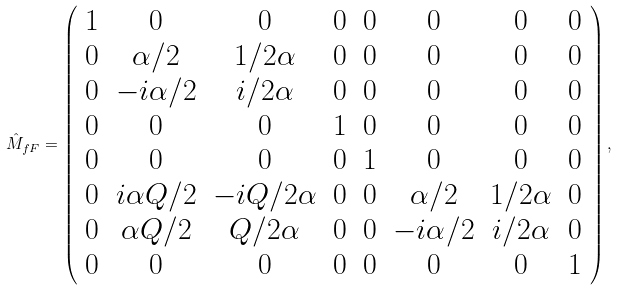Convert formula to latex. <formula><loc_0><loc_0><loc_500><loc_500>\hat { M } _ { f F } = \left ( \begin{array} { c c c c c c c c } 1 & 0 & 0 & 0 & 0 & 0 & 0 & 0 \\ 0 & \alpha / 2 & 1 / 2 \alpha & 0 & 0 & 0 & 0 & 0 \\ 0 & - i \alpha / 2 & i / 2 \alpha & 0 & 0 & 0 & 0 & 0 \\ 0 & 0 & 0 & 1 & 0 & 0 & 0 & 0 \\ 0 & 0 & 0 & 0 & 1 & 0 & 0 & 0 \\ 0 & i \alpha Q / 2 & - i Q / 2 \alpha & 0 & 0 & \alpha / 2 & 1 / 2 \alpha & 0 \\ 0 & \alpha Q / 2 & Q / 2 \alpha & 0 & 0 & - i \alpha / 2 & i / 2 \alpha & 0 \\ 0 & 0 & 0 & 0 & 0 & 0 & 0 & 1 \end{array} \right ) ,</formula> 